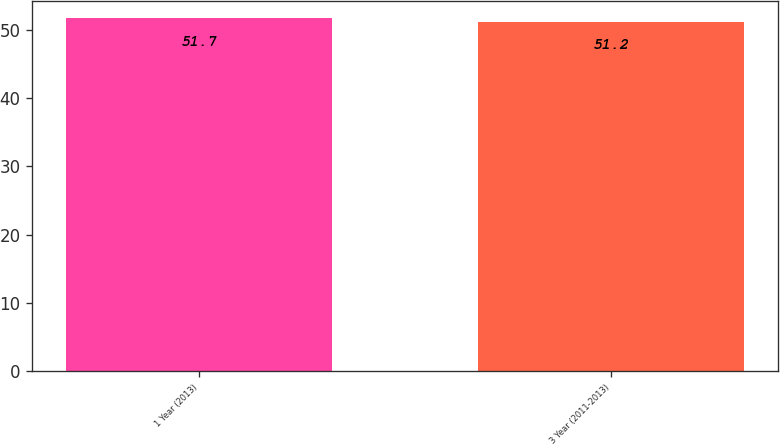Convert chart. <chart><loc_0><loc_0><loc_500><loc_500><bar_chart><fcel>1 Year (2013)<fcel>3 Year (2011-2013)<nl><fcel>51.7<fcel>51.2<nl></chart> 